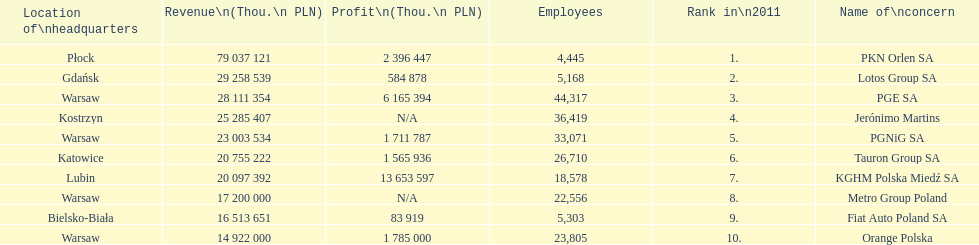What company has the top number of employees? PGE SA. 